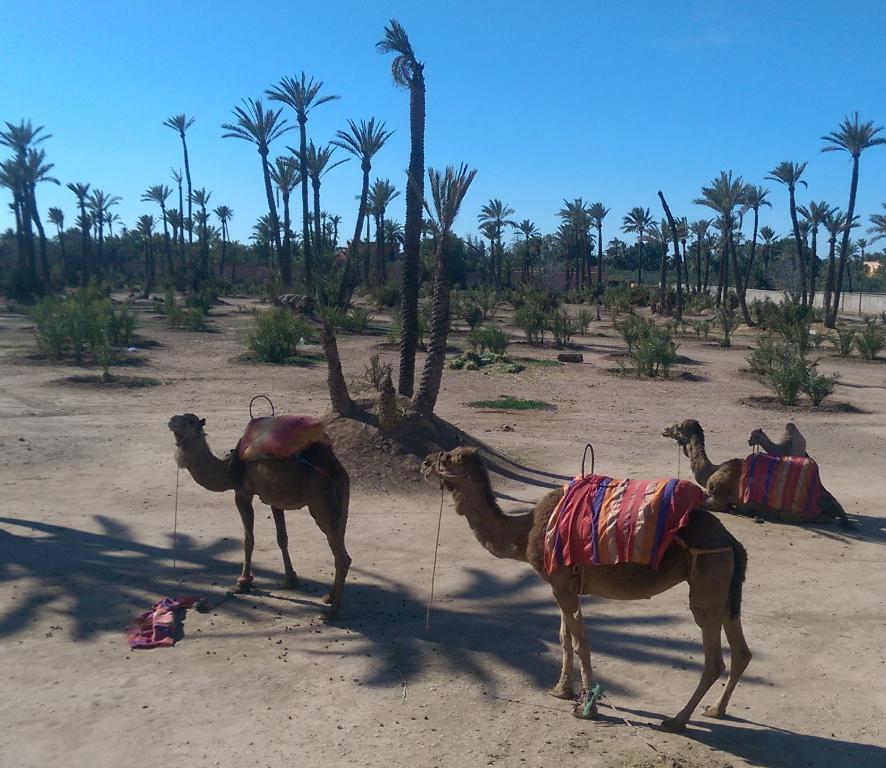Could you give a brief overview of what you see in this image? In this image we can see some camels, there are plants, trees and the wall, in the background we can see the sky. 